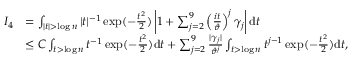<formula> <loc_0><loc_0><loc_500><loc_500>\begin{array} { r l } { I _ { 4 } } & { = \int _ { | t | > \log n } | t | ^ { - 1 } \exp ( - \frac { t ^ { 2 } } { 2 } ) \left | 1 + \sum _ { j = 2 } ^ { 9 } \left ( \frac { i t } { \vartheta } \right ) ^ { j } \gamma _ { j } \right | d t } \\ & { \leq C \int _ { t > \log n } t ^ { - 1 } \exp ( - \frac { t ^ { 2 } } { 2 } ) d t + \sum _ { j = 2 } ^ { 9 } \frac { | \gamma _ { j } | } { \vartheta ^ { j } } \int _ { t > \log n } t ^ { j - 1 } \exp ( - \frac { t ^ { 2 } } { 2 } ) d t , } \end{array}</formula> 